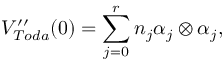<formula> <loc_0><loc_0><loc_500><loc_500>V _ { T o d a } ^ { \prime \prime } ( 0 ) = \sum _ { j = 0 } ^ { r } n _ { j } \alpha _ { j } \otimes \alpha _ { j } ,</formula> 